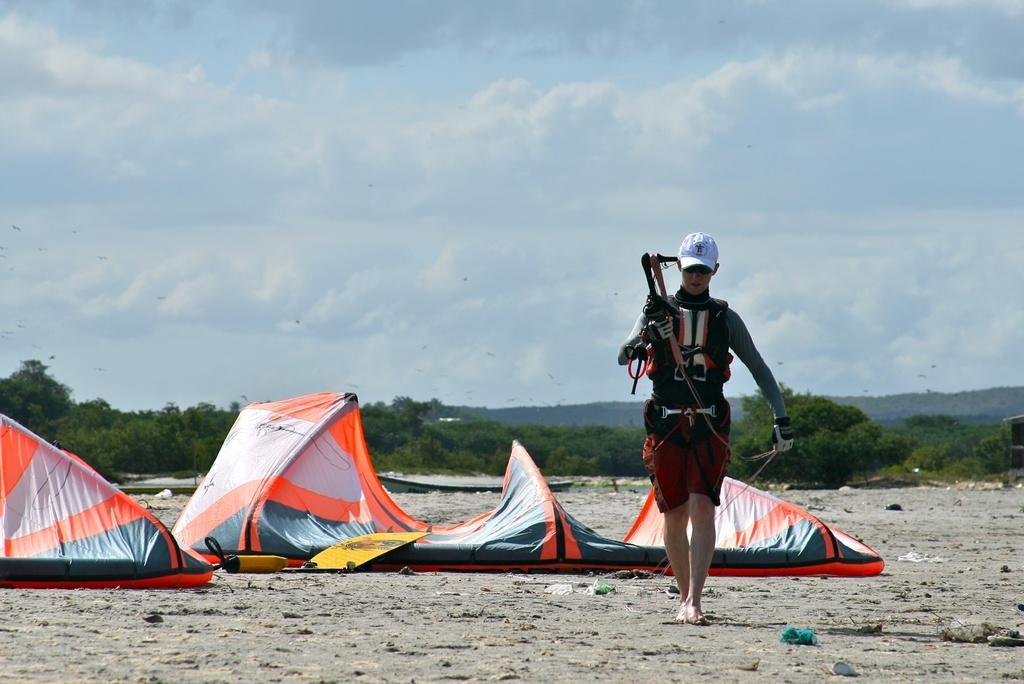Please provide a concise description of this image. There is one person standing on the right side is wearing a jacket and a white color cap. There are some tents on the left side of this image. There are some trees in the background. There is a cloudy sky at the top of this image. 